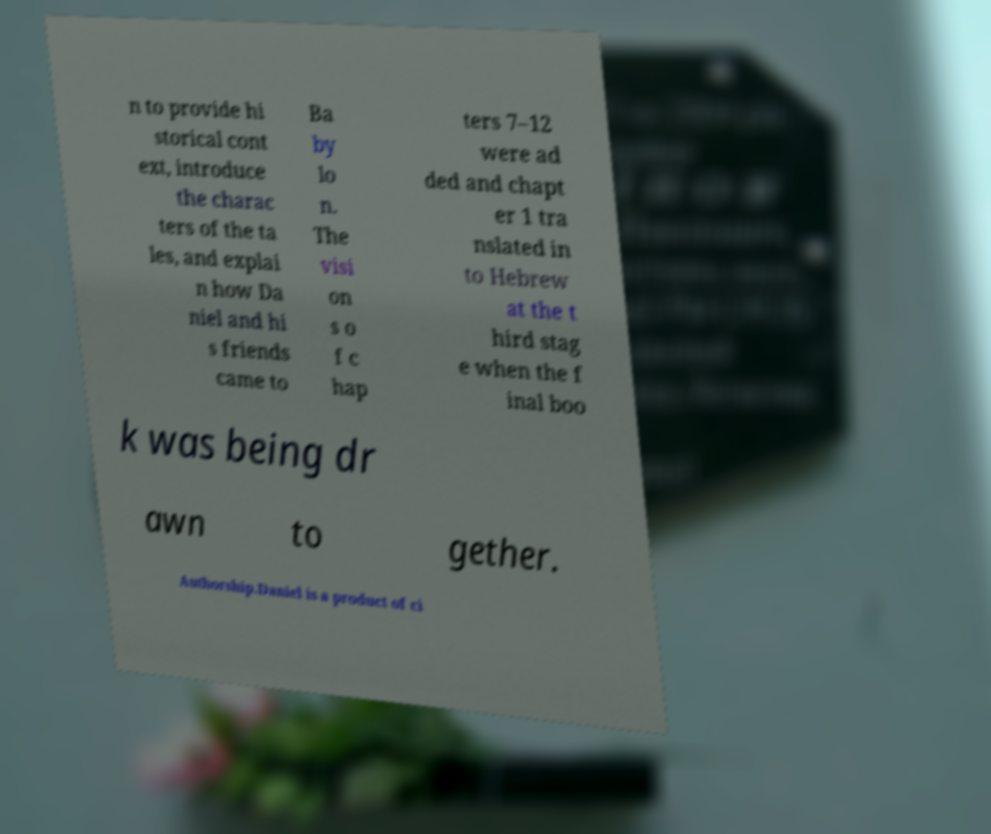Could you extract and type out the text from this image? n to provide hi storical cont ext, introduce the charac ters of the ta les, and explai n how Da niel and hi s friends came to Ba by lo n. The visi on s o f c hap ters 7–12 were ad ded and chapt er 1 tra nslated in to Hebrew at the t hird stag e when the f inal boo k was being dr awn to gether. Authorship.Daniel is a product of ci 